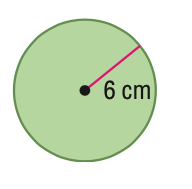Question: Find the area of the circle. Round to the nearest tenth.
Choices:
A. 18.8
B. 37.7
C. 113.1
D. 452.4
Answer with the letter. Answer: C 